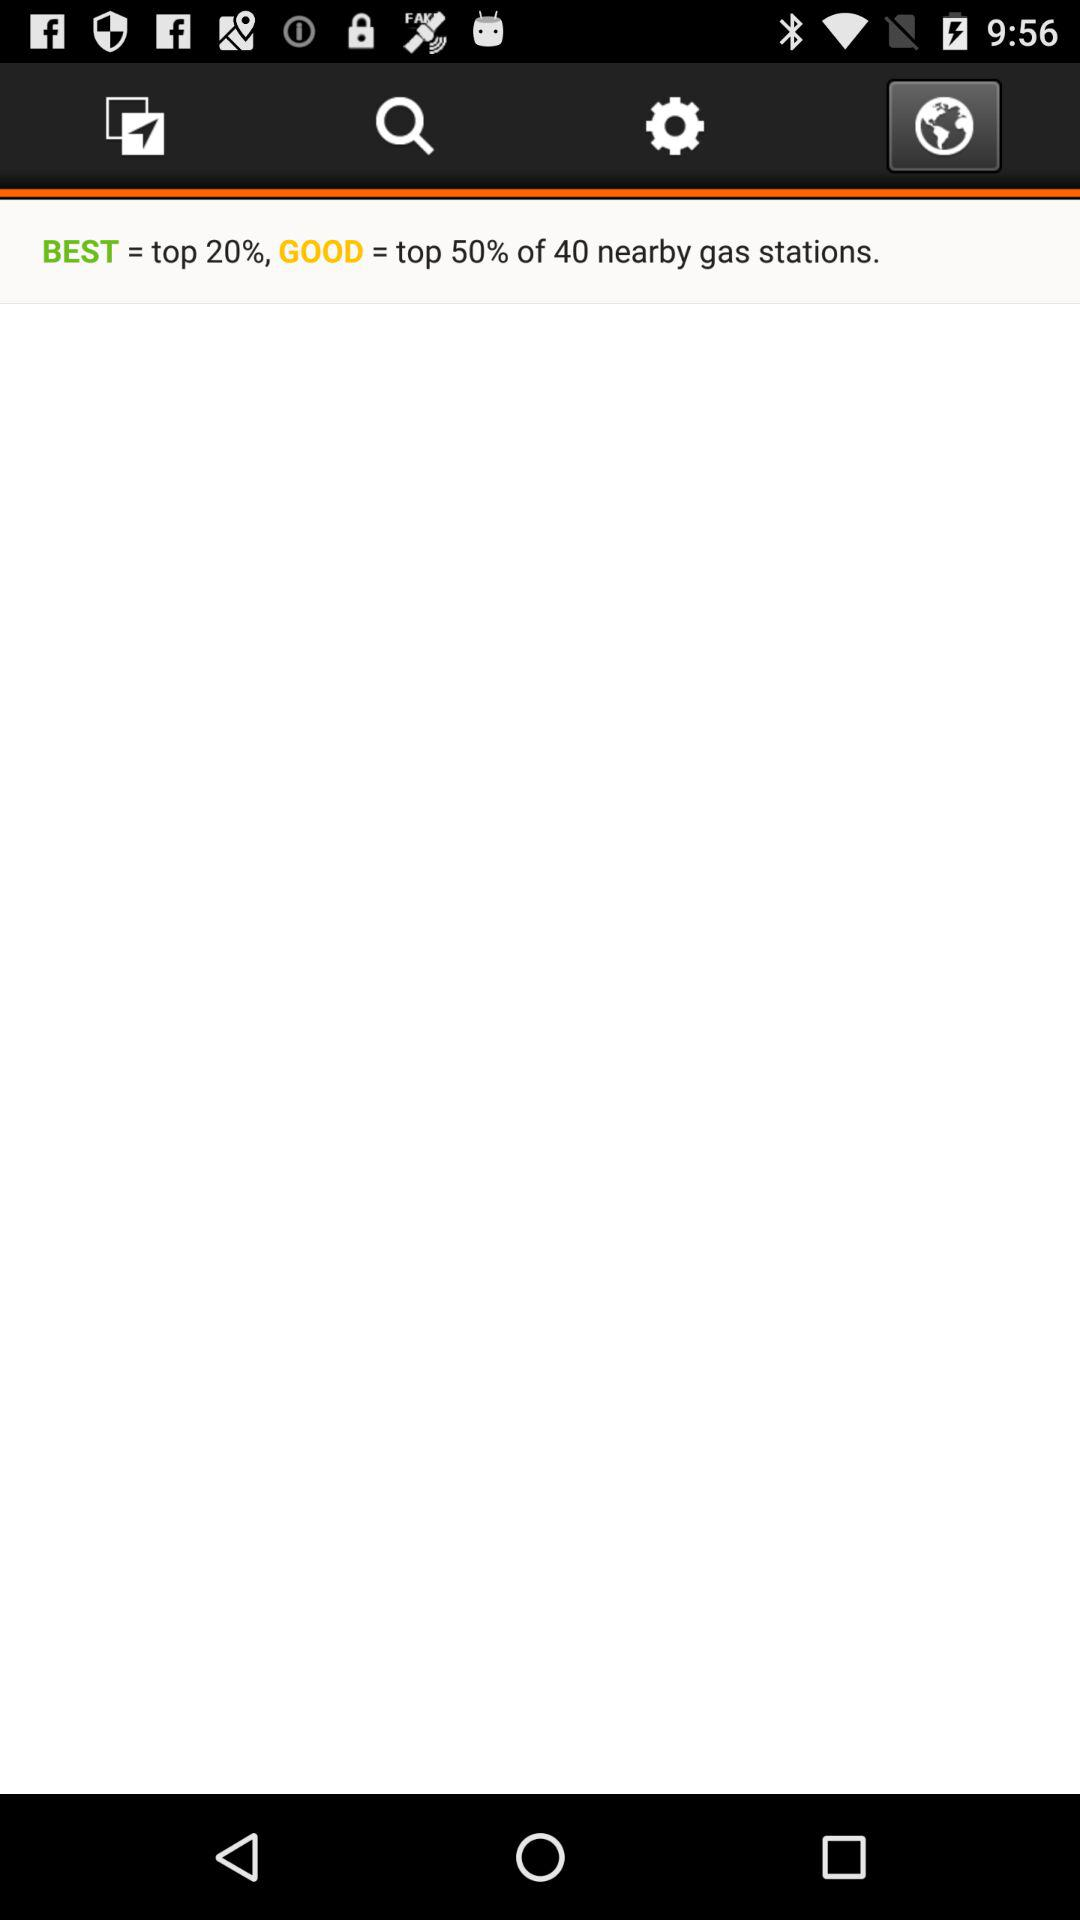How many percent of the nearby gas stations are good?
Answer the question using a single word or phrase. 50% 